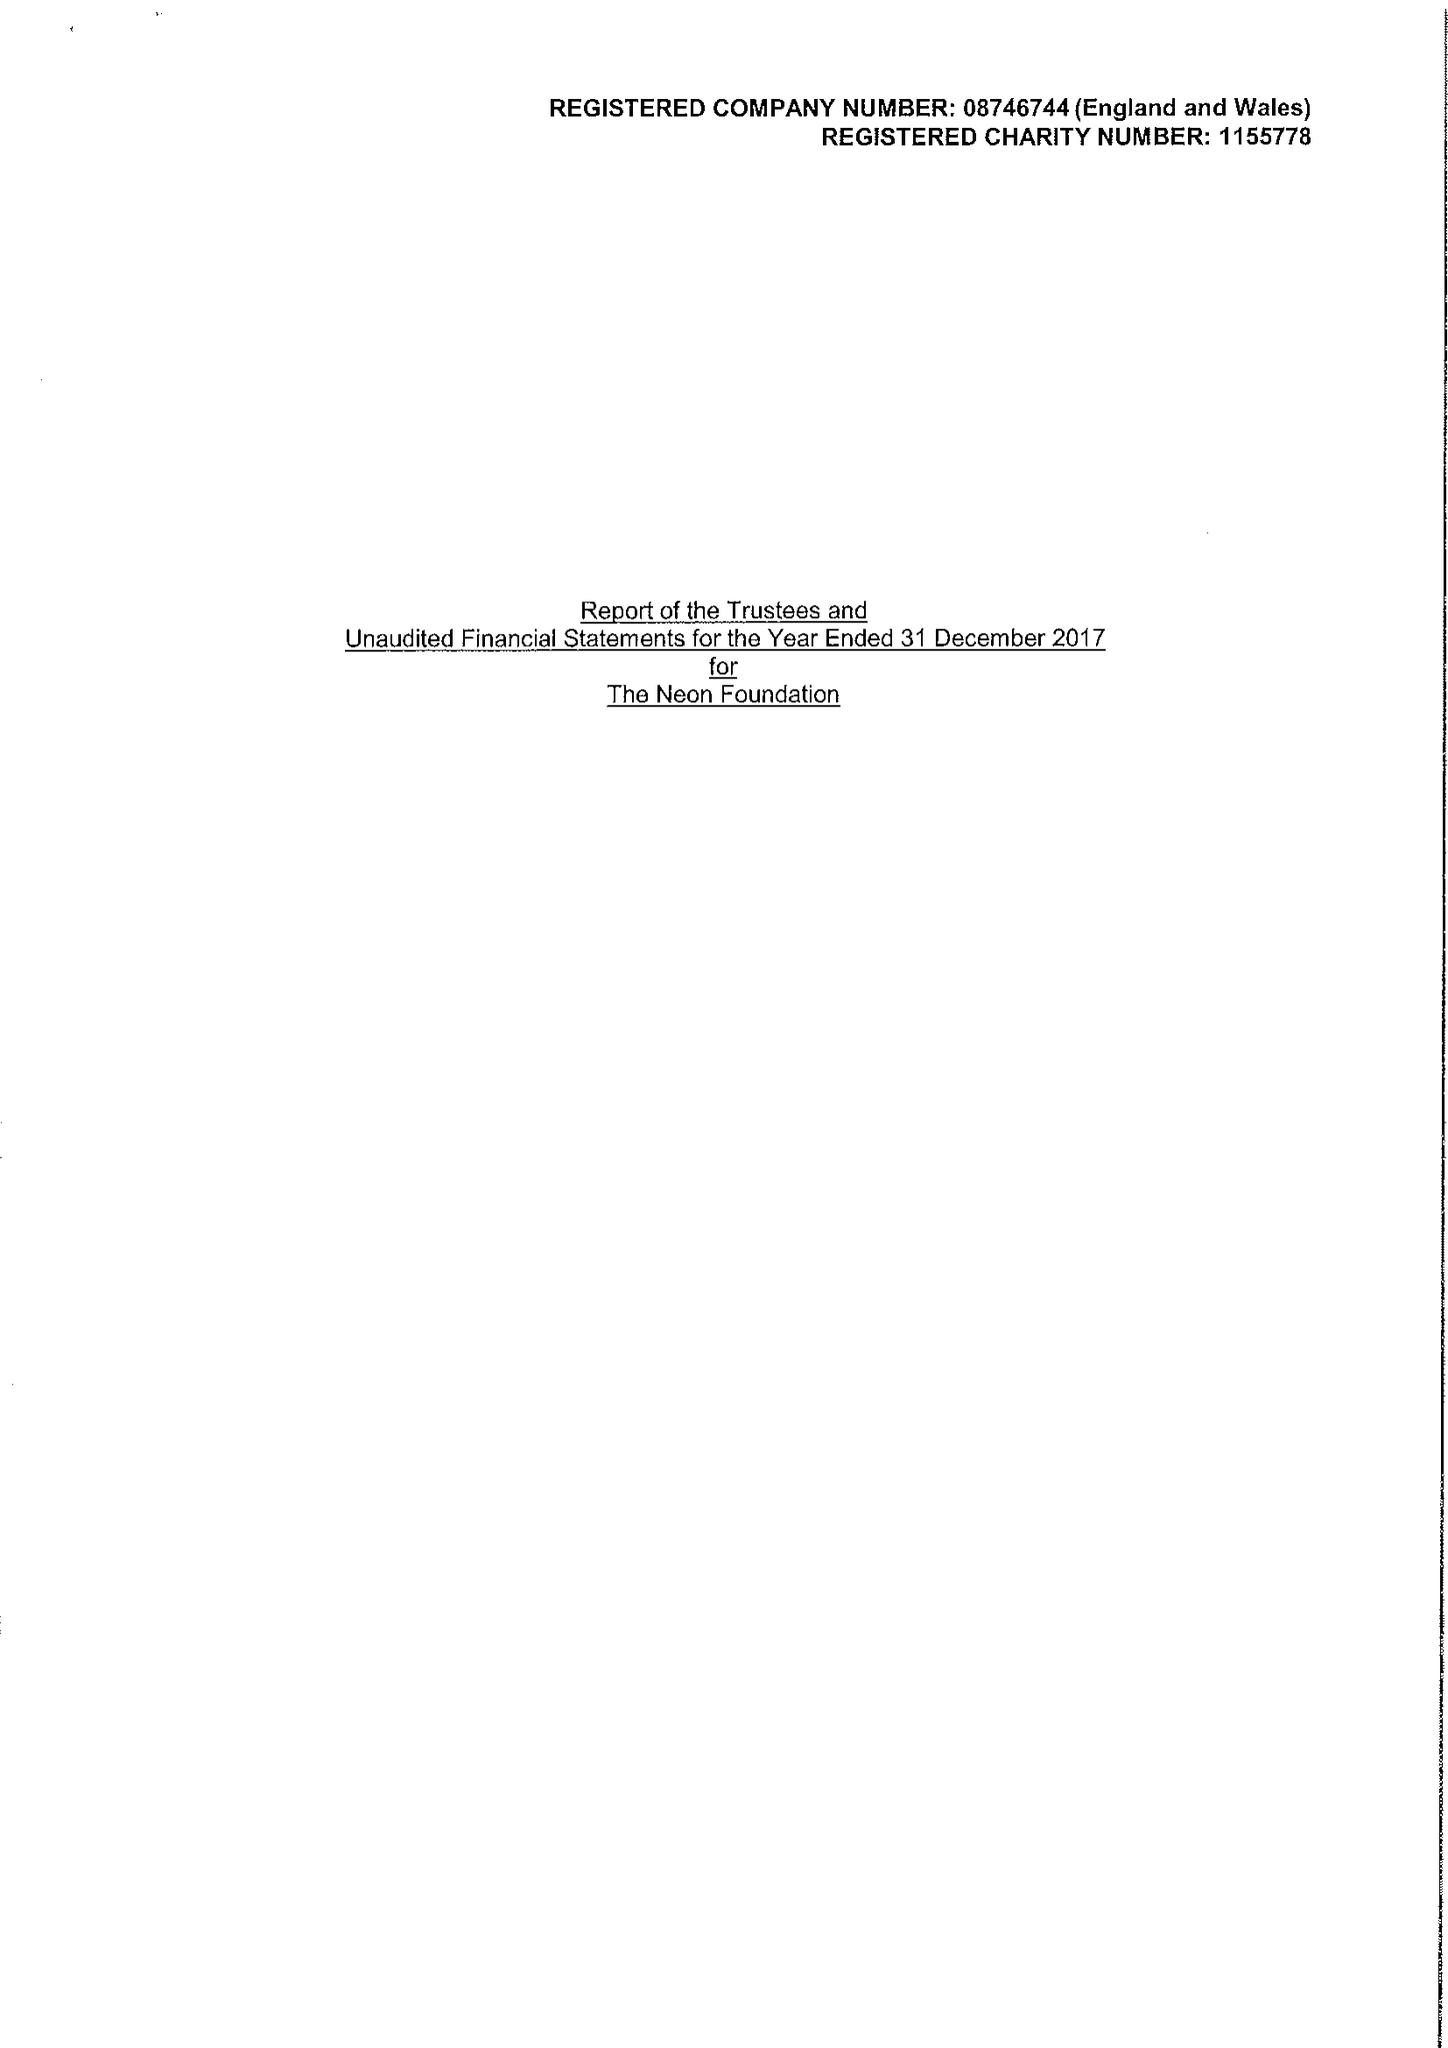What is the value for the address__post_town?
Answer the question using a single word or phrase. LONDON 